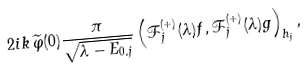<formula> <loc_0><loc_0><loc_500><loc_500>2 i k \, \widetilde { \varphi } ( 0 ) \frac { \pi } { \sqrt { \lambda - E _ { 0 , j } } } \left ( \mathcal { F } _ { j } ^ { ( + ) } ( \lambda ) f , \mathcal { F } _ { j } ^ { ( + ) } ( \lambda ) g \right ) _ { { h } _ { j } } ,</formula> 